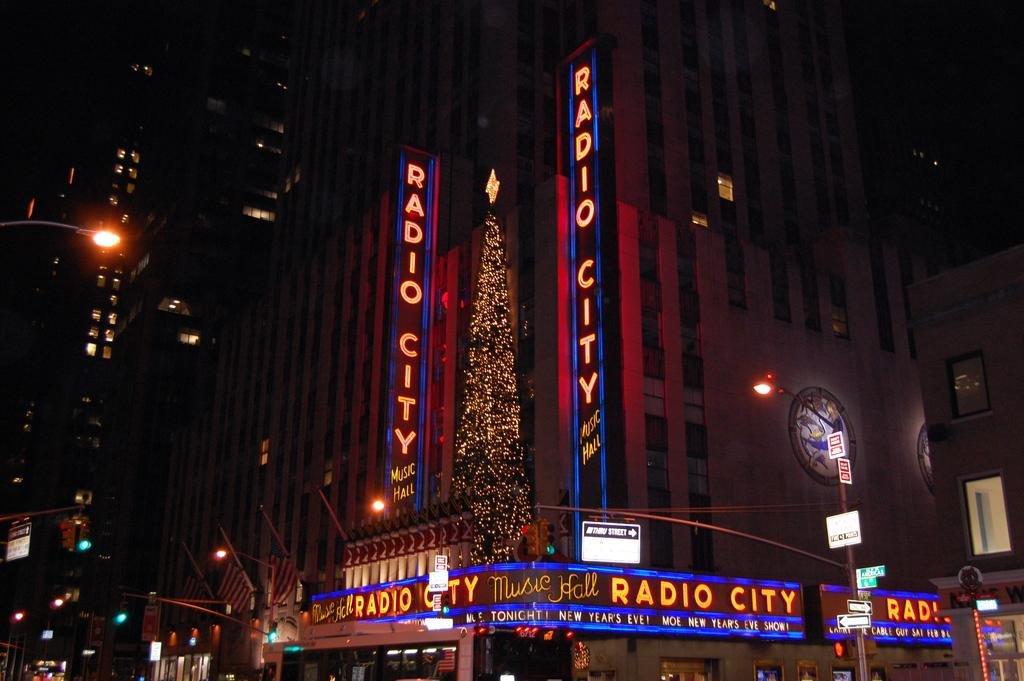What type of structures are present in the image? There are buildings in the image. What feature do the buildings have? The buildings have lights. What else can be seen on poles in the image? There are poles with lights and boards in the image. Can you read any text in the image? Yes, there are words visible in the image. Is there a spot where people can gather for a feast in the image? There is no specific spot for a feast mentioned or visible in the image. Can you see a bridge connecting two areas in the image? There is no bridge visible in the image. 